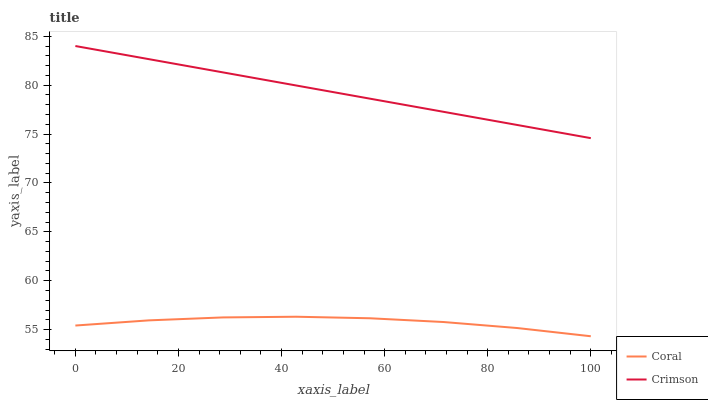Does Coral have the maximum area under the curve?
Answer yes or no. No. Is Coral the smoothest?
Answer yes or no. No. Does Coral have the highest value?
Answer yes or no. No. Is Coral less than Crimson?
Answer yes or no. Yes. Is Crimson greater than Coral?
Answer yes or no. Yes. Does Coral intersect Crimson?
Answer yes or no. No. 